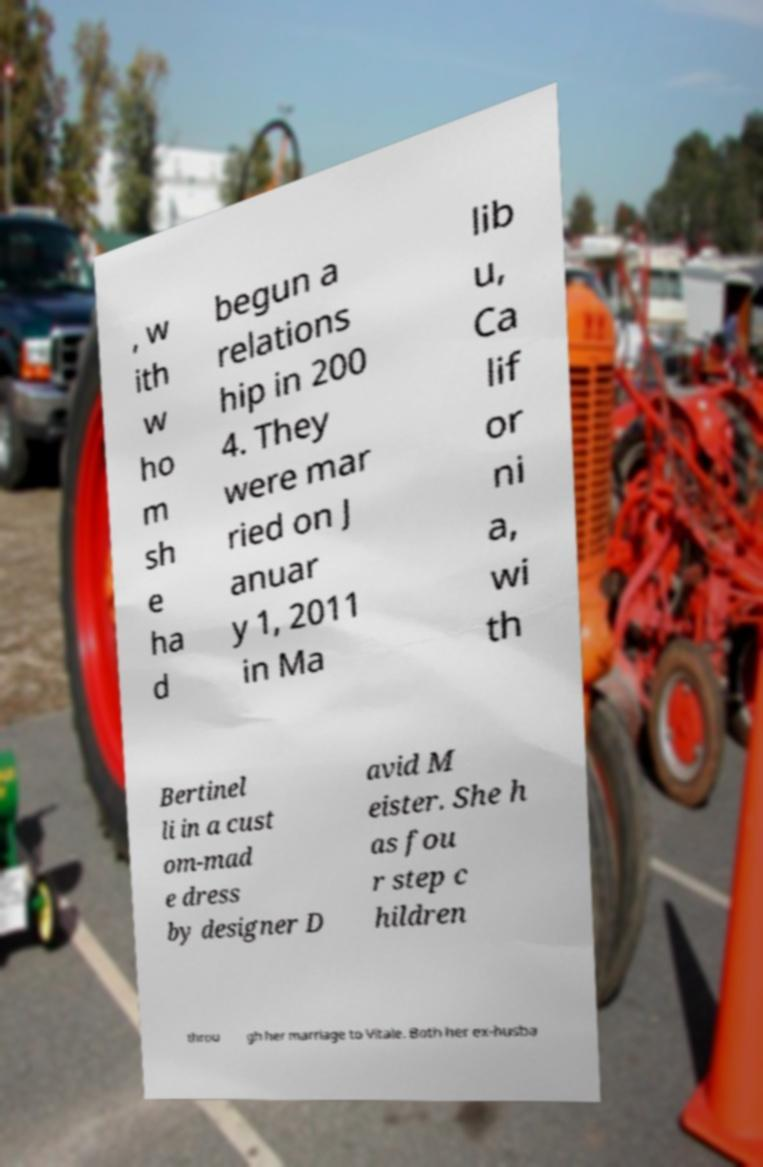Please identify and transcribe the text found in this image. , w ith w ho m sh e ha d begun a relations hip in 200 4. They were mar ried on J anuar y 1, 2011 in Ma lib u, Ca lif or ni a, wi th Bertinel li in a cust om-mad e dress by designer D avid M eister. She h as fou r step c hildren throu gh her marriage to Vitale. Both her ex-husba 